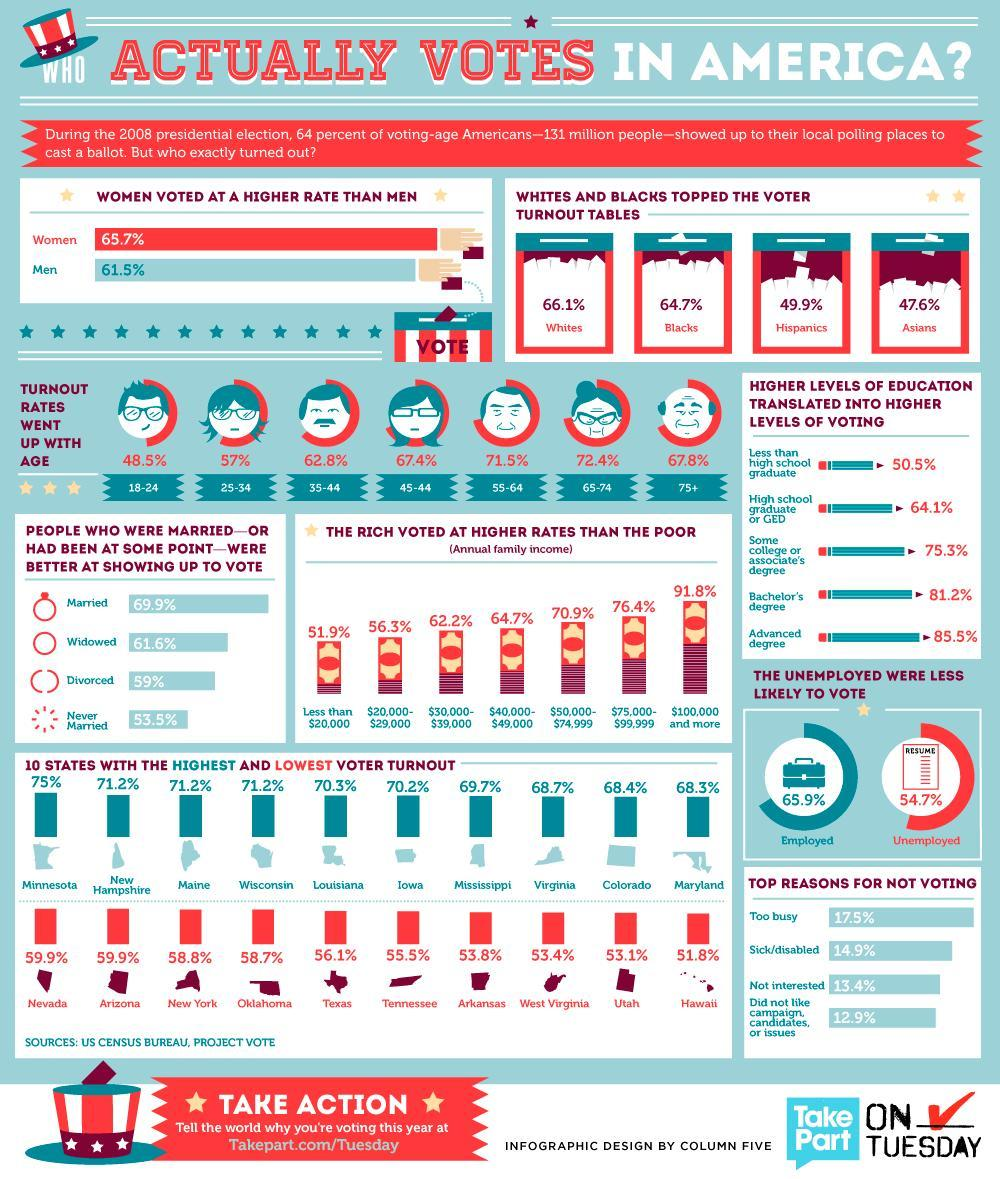People belonging to which culture has the third-highest polling?
Answer the question with a short phrase. Hispanics What is the polling rate of Hispanics and Asians took together? 97.5% People belonging to which age category have polled the highest? 65-74 What is the annual income of people in America who have marked the second-highest polling? $75,000-$99,999 How many different races are there in America other than Whites? 3 Which state in America has the second-lowest polling rate? Utah People of what educational background marked the second-highest polling? Bachelor's degree What is the color code for women- blue, red, pink, green? red Which state in America has the third-lowest polling rate? West Virginia People belonging to which age category marked the second-highest polling? 55-64 